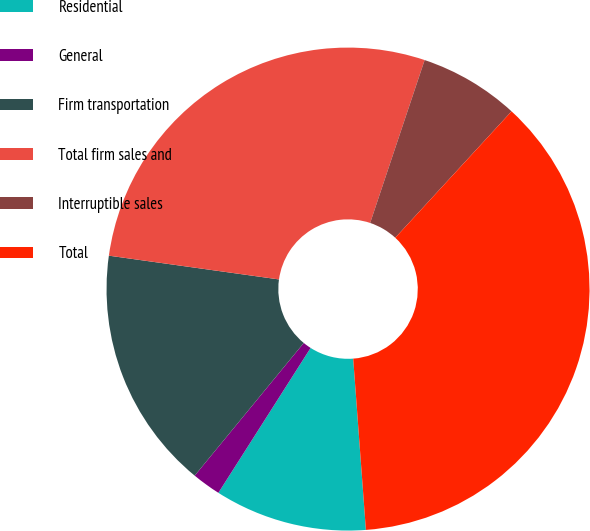Convert chart to OTSL. <chart><loc_0><loc_0><loc_500><loc_500><pie_chart><fcel>Residential<fcel>General<fcel>Firm transportation<fcel>Total firm sales and<fcel>Interruptible sales<fcel>Total<nl><fcel>10.2%<fcel>1.93%<fcel>16.26%<fcel>27.93%<fcel>6.7%<fcel>36.99%<nl></chart> 